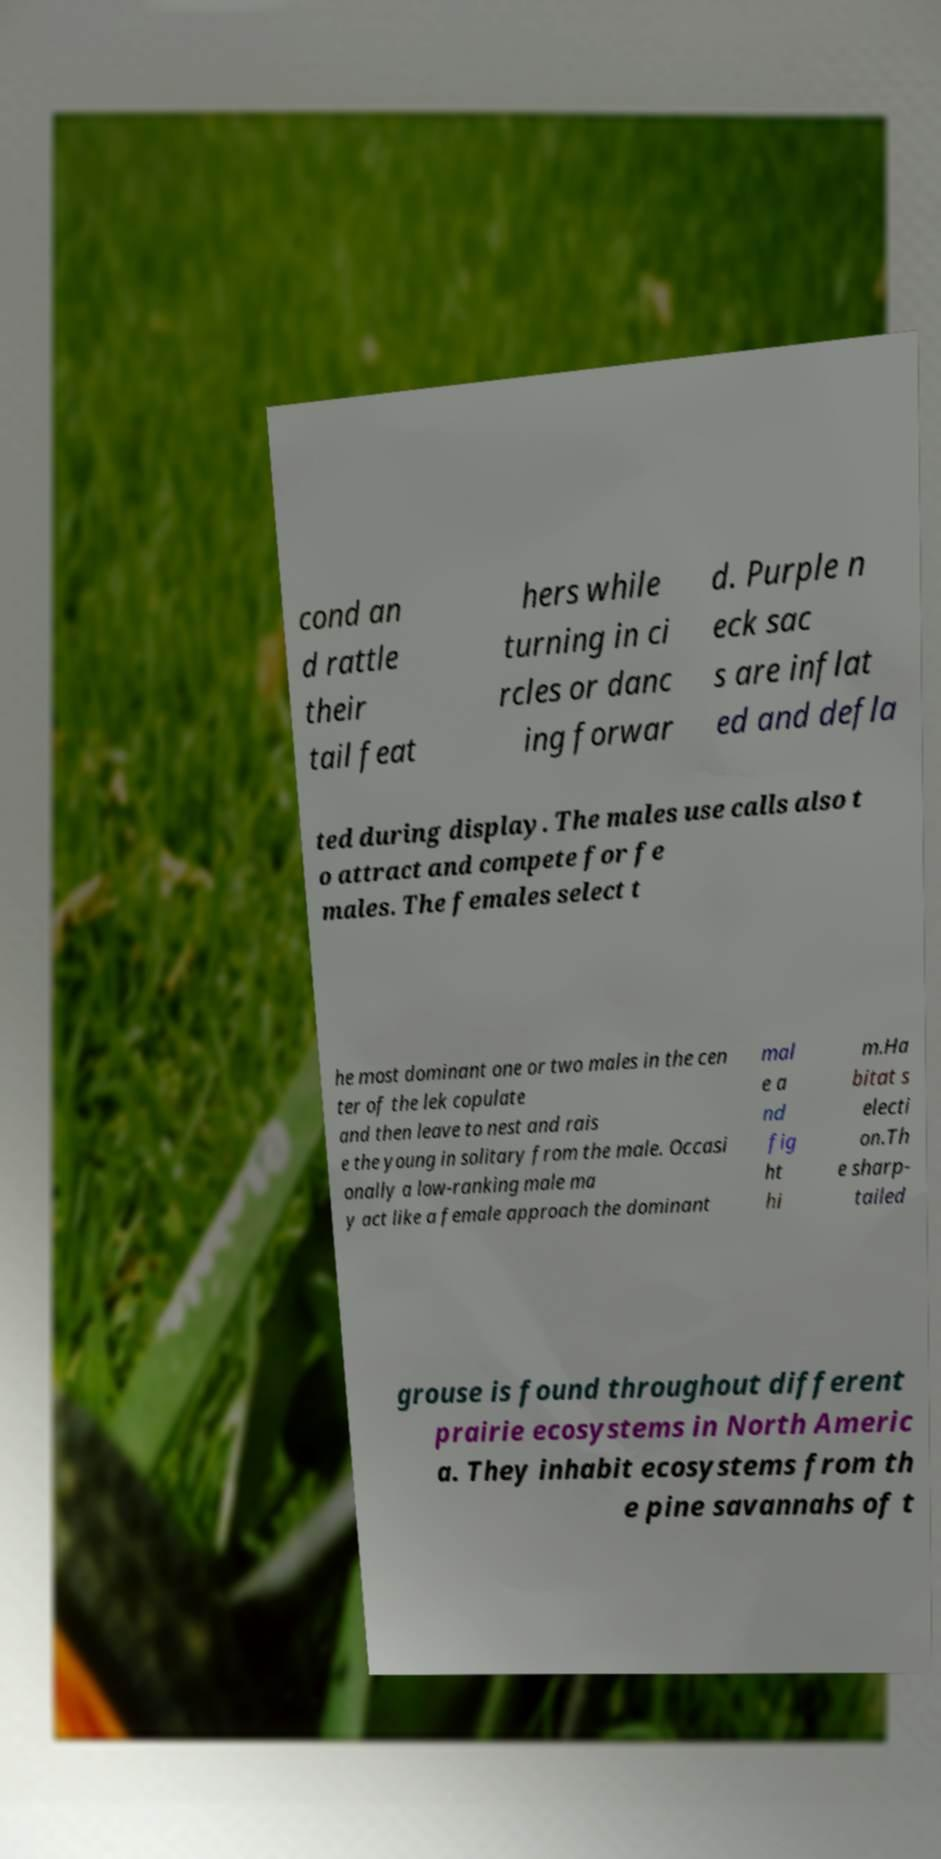Could you extract and type out the text from this image? cond an d rattle their tail feat hers while turning in ci rcles or danc ing forwar d. Purple n eck sac s are inflat ed and defla ted during display. The males use calls also t o attract and compete for fe males. The females select t he most dominant one or two males in the cen ter of the lek copulate and then leave to nest and rais e the young in solitary from the male. Occasi onally a low-ranking male ma y act like a female approach the dominant mal e a nd fig ht hi m.Ha bitat s electi on.Th e sharp- tailed grouse is found throughout different prairie ecosystems in North Americ a. They inhabit ecosystems from th e pine savannahs of t 